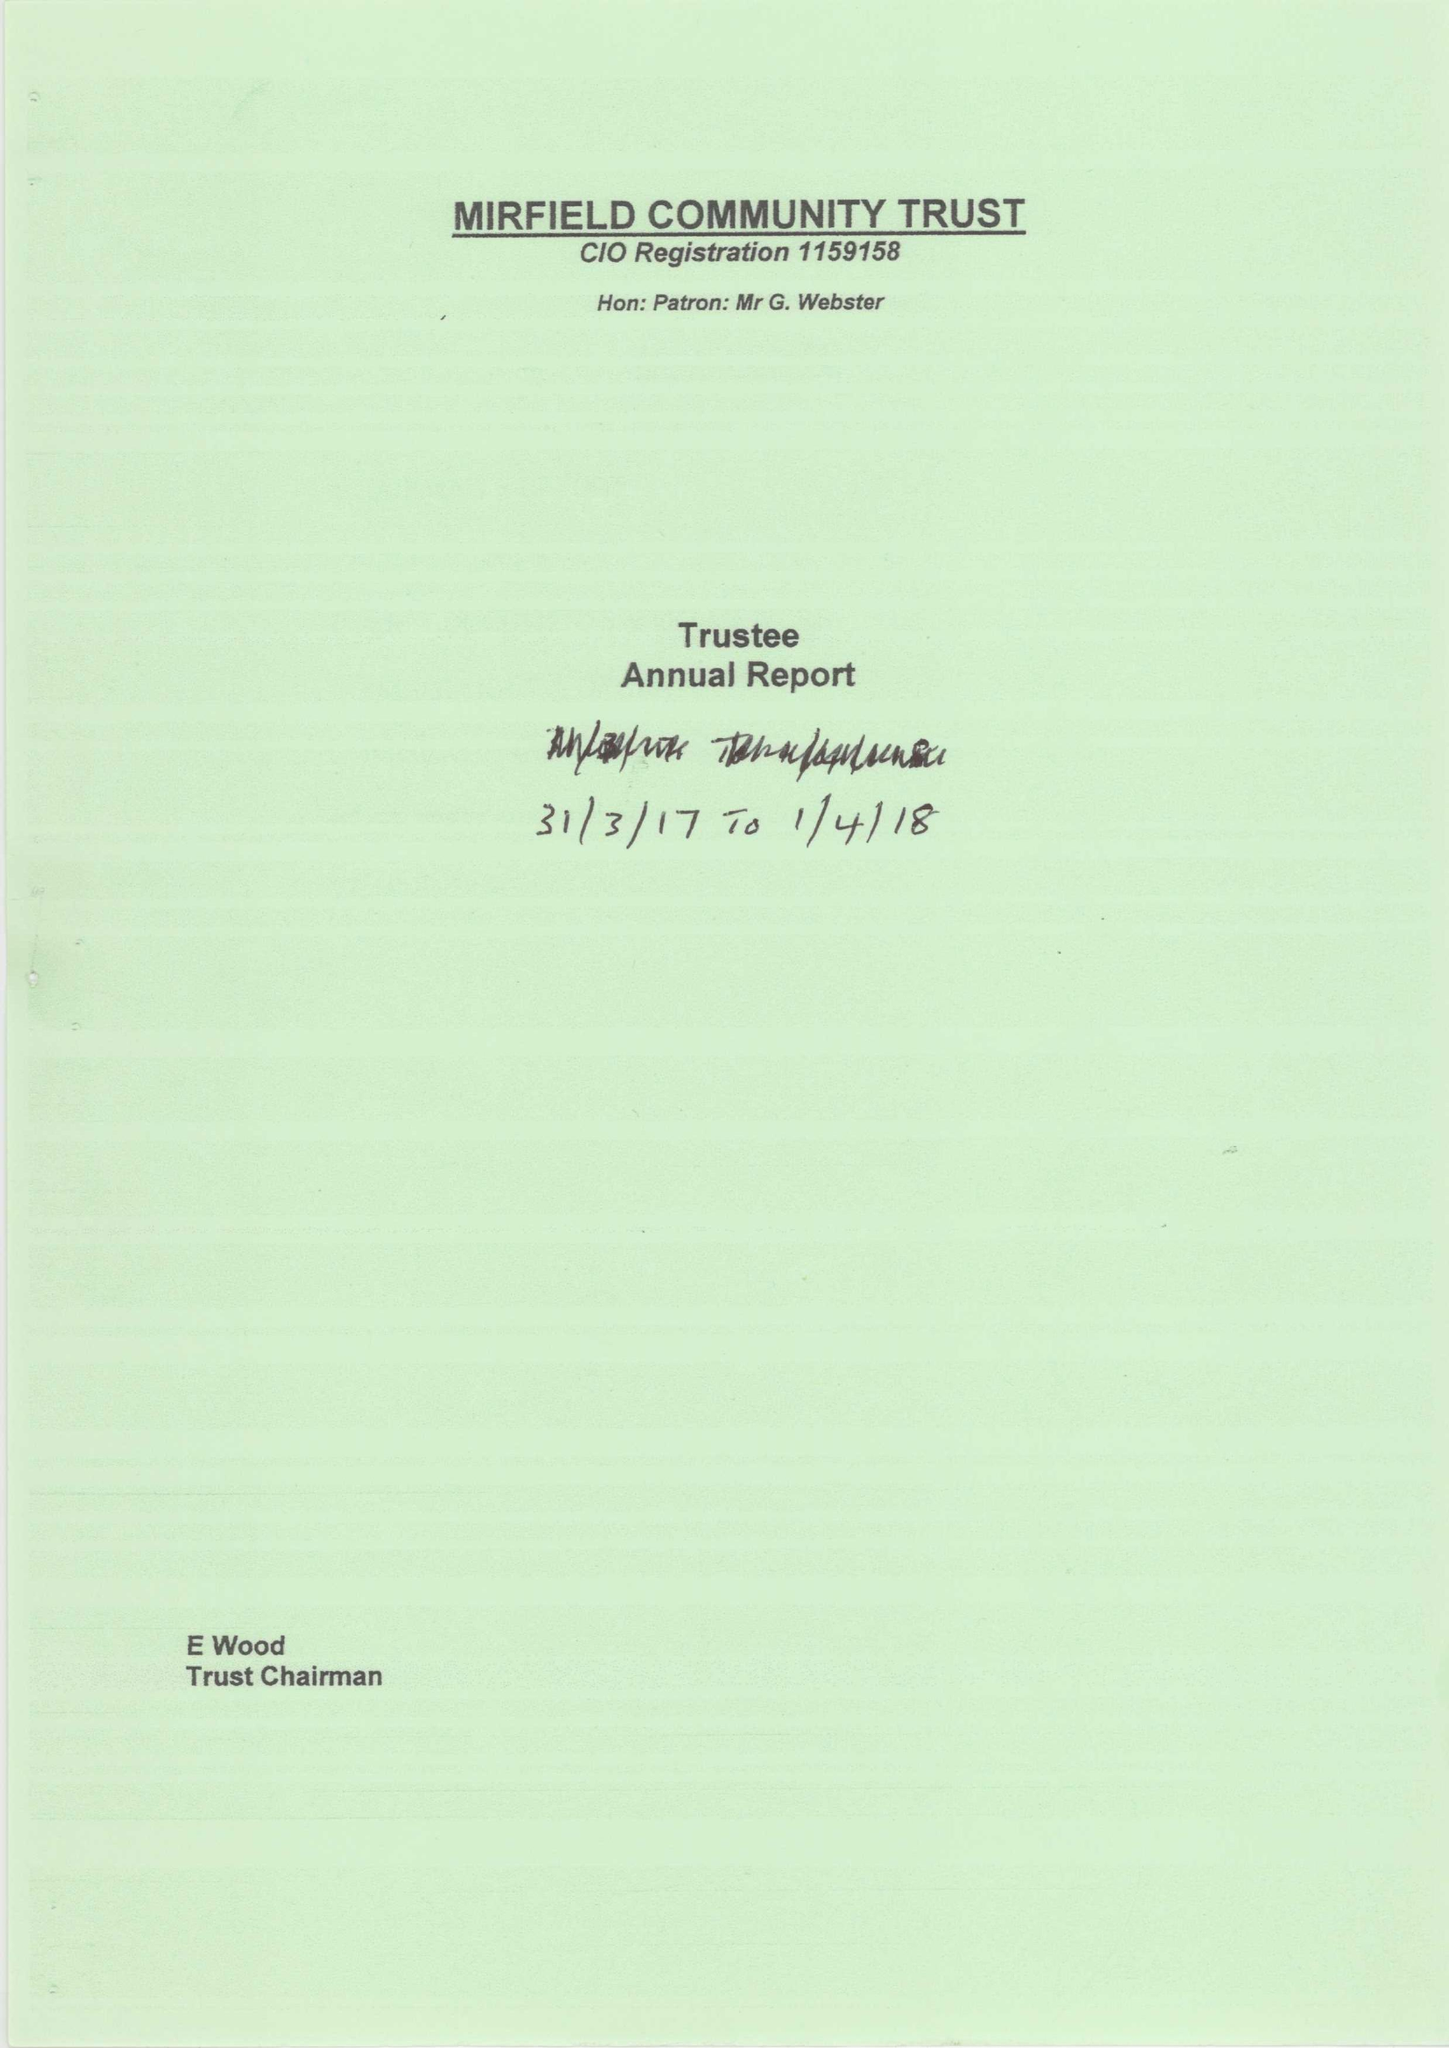What is the value for the charity_number?
Answer the question using a single word or phrase. 1159158 